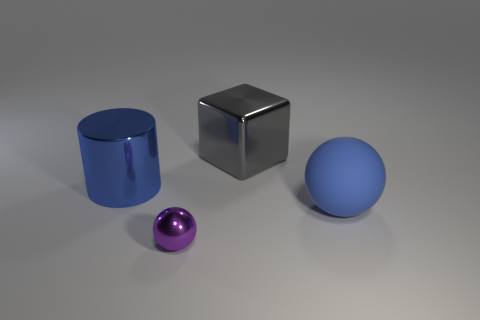Are there more large objects behind the large block than yellow cylinders?
Provide a short and direct response. No. The big metal thing that is the same color as the rubber thing is what shape?
Provide a short and direct response. Cylinder. Is there a large gray object that has the same material as the tiny object?
Make the answer very short. Yes. Does the blue object that is behind the big blue ball have the same material as the ball that is behind the small shiny sphere?
Ensure brevity in your answer.  No. Are there the same number of big balls behind the big gray object and small purple balls in front of the small ball?
Give a very brief answer. Yes. What is the color of the shiny block that is the same size as the blue matte object?
Your answer should be very brief. Gray. Are there any other rubber objects of the same color as the large matte object?
Ensure brevity in your answer.  No. What number of objects are either metal things that are on the left side of the purple sphere or brown metallic objects?
Keep it short and to the point. 1. What number of other things are the same size as the purple sphere?
Provide a short and direct response. 0. The large blue thing in front of the blue thing that is behind the big thing on the right side of the metallic cube is made of what material?
Keep it short and to the point. Rubber. 